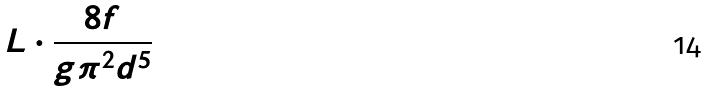Convert formula to latex. <formula><loc_0><loc_0><loc_500><loc_500>L \cdot \frac { 8 f } { g \pi ^ { 2 } d ^ { 5 } }</formula> 